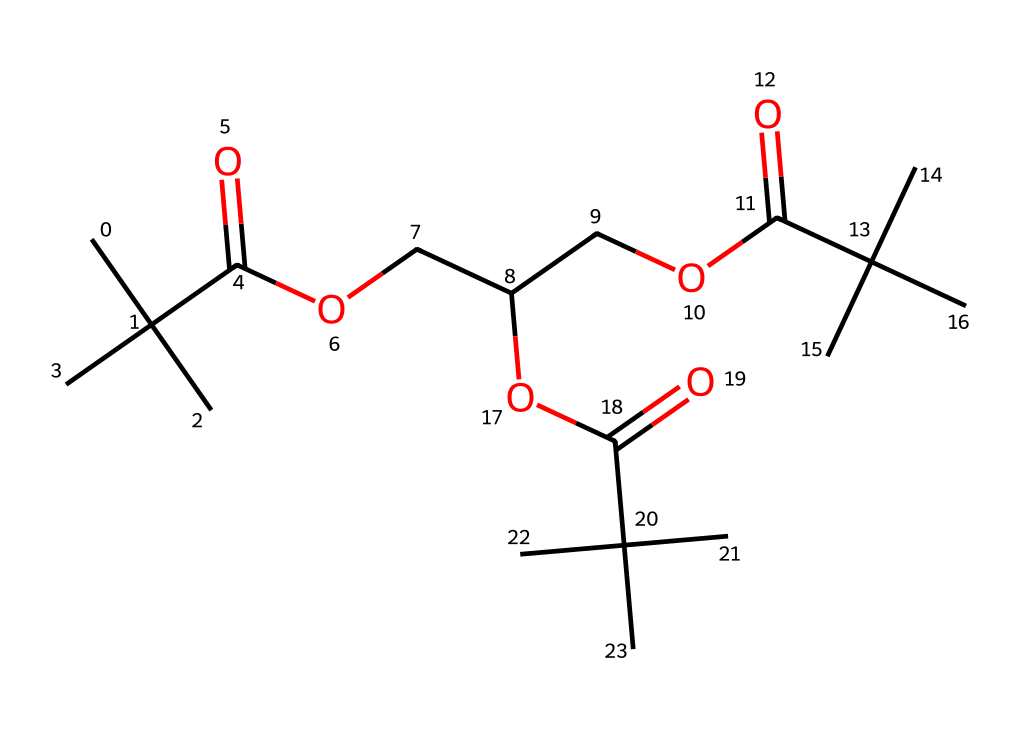How many carbon atoms are present in the structure? To determine the number of carbon atoms, we can break down the SMILES notation and count every 'C'. In the provided SMILES, there are a total of 15 'C' characters, indicating 15 carbon atoms.
Answer: 15 What functional groups are present in this compound? By analyzing the structure, we can identify that there are ester functional groups (indicated by the presence of 'C(=O)O') and carboxylic acid (due to 'C(=O)O'). Each 'C(=O)O' suggests an ester or carboxylic acid depending on the context, but the presence of multiple such patterns confirms their existence.
Answer: ester and carboxylic acid What type of polymer structure does this compound represent? This compound has a branched polymer structure indicated by its multiple carbon chains and functional groups that provide branching rather than a linear form. The numerous alkyl groups (like 'C(C)(C)') also imply a branched arrangement.
Answer: branched Estimate the degree of branching in the polymer. The degree of branching can be estimated by observing the number of branching points, which are represented by groups like '(C)(C)'. In this structure, there are several such instances, indicating a significant degree of branching, likely above four main branches.
Answer: high What type of solid does this polymer likely represent in computer peripherals? This polymer likely represents a thermoplastic elastomer, which is commonly used in the manufacturing of various computer peripherals due to its flexible and durable nature. The presence of ester linkages supports this classification.
Answer: thermoplastic elastomer 